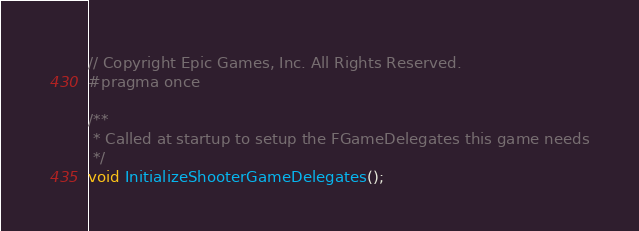<code> <loc_0><loc_0><loc_500><loc_500><_C_>// Copyright Epic Games, Inc. All Rights Reserved.
#pragma once

/**
 * Called at startup to setup the FGameDelegates this game needs
 */
void InitializeShooterGameDelegates();
</code> 